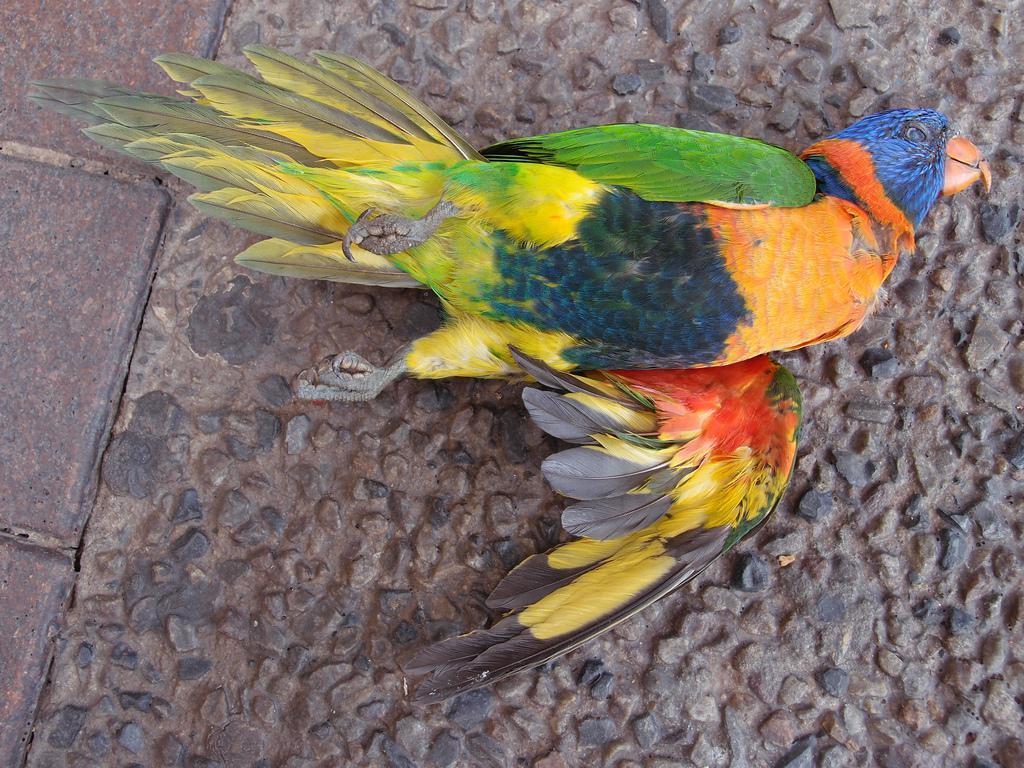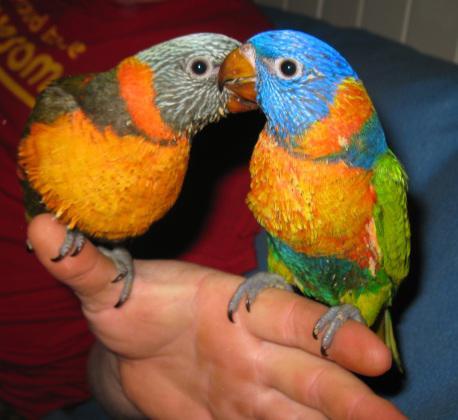The first image is the image on the left, the second image is the image on the right. For the images shown, is this caption "In one of the images there are two colorful birds standing next to each other." true? Answer yes or no. Yes. The first image is the image on the left, the second image is the image on the right. Evaluate the accuracy of this statement regarding the images: "One image features two multicolored parrots side-by-side.". Is it true? Answer yes or no. Yes. 